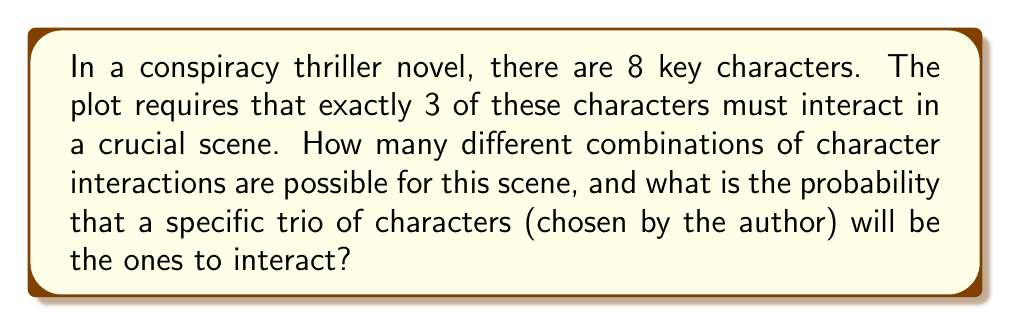Can you answer this question? Let's approach this step-by-step:

1) First, we need to calculate the number of ways to choose 3 characters from 8. This is a combination problem, denoted as $\binom{8}{3}$ or C(8,3).

2) The formula for this combination is:

   $$\binom{8}{3} = \frac{8!}{3!(8-3)!} = \frac{8!}{3!5!}$$

3) Let's calculate this:
   
   $$\frac{8 \cdot 7 \cdot 6 \cdot 5!}{(3 \cdot 2 \cdot 1) \cdot 5!} = \frac{336}{6} = 56$$

4) So there are 56 different possible combinations of 3 characters that could interact.

5) Now, for the probability that a specific trio will be the ones to interact:
   
   There is only 1 way for this specific trio to be chosen out of the 56 possible combinations.

6) The probability is therefore:

   $$P(\text{specific trio}) = \frac{1}{56}$$
Answer: 56 combinations; probability = $\frac{1}{56}$ 